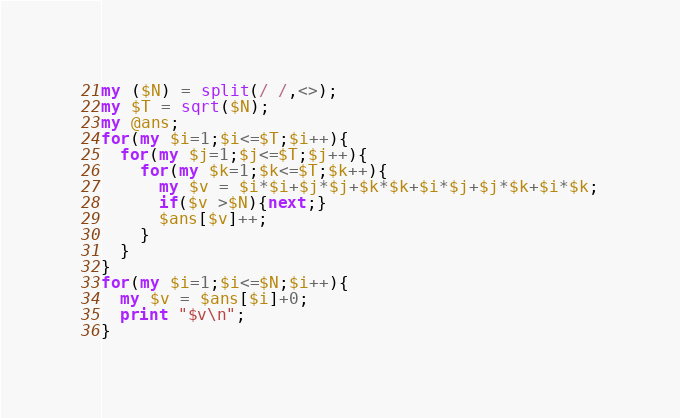<code> <loc_0><loc_0><loc_500><loc_500><_Perl_>my ($N) = split(/ /,<>);
my $T = sqrt($N);
my @ans;
for(my $i=1;$i<=$T;$i++){
  for(my $j=1;$j<=$T;$j++){
    for(my $k=1;$k<=$T;$k++){
      my $v = $i*$i+$j*$j+$k*$k+$i*$j+$j*$k+$i*$k;
      if($v >$N){next;}
      $ans[$v]++;
    }
  }
}
for(my $i=1;$i<=$N;$i++){
  my $v = $ans[$i]+0;
  print "$v\n";
}</code> 